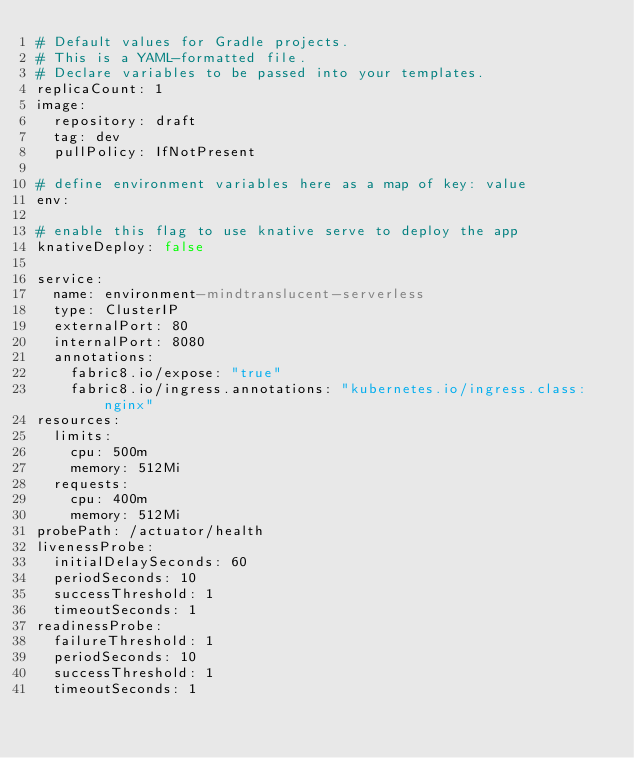Convert code to text. <code><loc_0><loc_0><loc_500><loc_500><_YAML_># Default values for Gradle projects.
# This is a YAML-formatted file.
# Declare variables to be passed into your templates.
replicaCount: 1
image:
  repository: draft
  tag: dev
  pullPolicy: IfNotPresent

# define environment variables here as a map of key: value
env:

# enable this flag to use knative serve to deploy the app
knativeDeploy: false

service:
  name: environment-mindtranslucent-serverless
  type: ClusterIP
  externalPort: 80
  internalPort: 8080
  annotations:
    fabric8.io/expose: "true"
    fabric8.io/ingress.annotations: "kubernetes.io/ingress.class: nginx"
resources:
  limits:
    cpu: 500m
    memory: 512Mi
  requests:
    cpu: 400m
    memory: 512Mi
probePath: /actuator/health
livenessProbe:
  initialDelaySeconds: 60
  periodSeconds: 10
  successThreshold: 1
  timeoutSeconds: 1
readinessProbe:
  failureThreshold: 1
  periodSeconds: 10
  successThreshold: 1
  timeoutSeconds: 1
</code> 